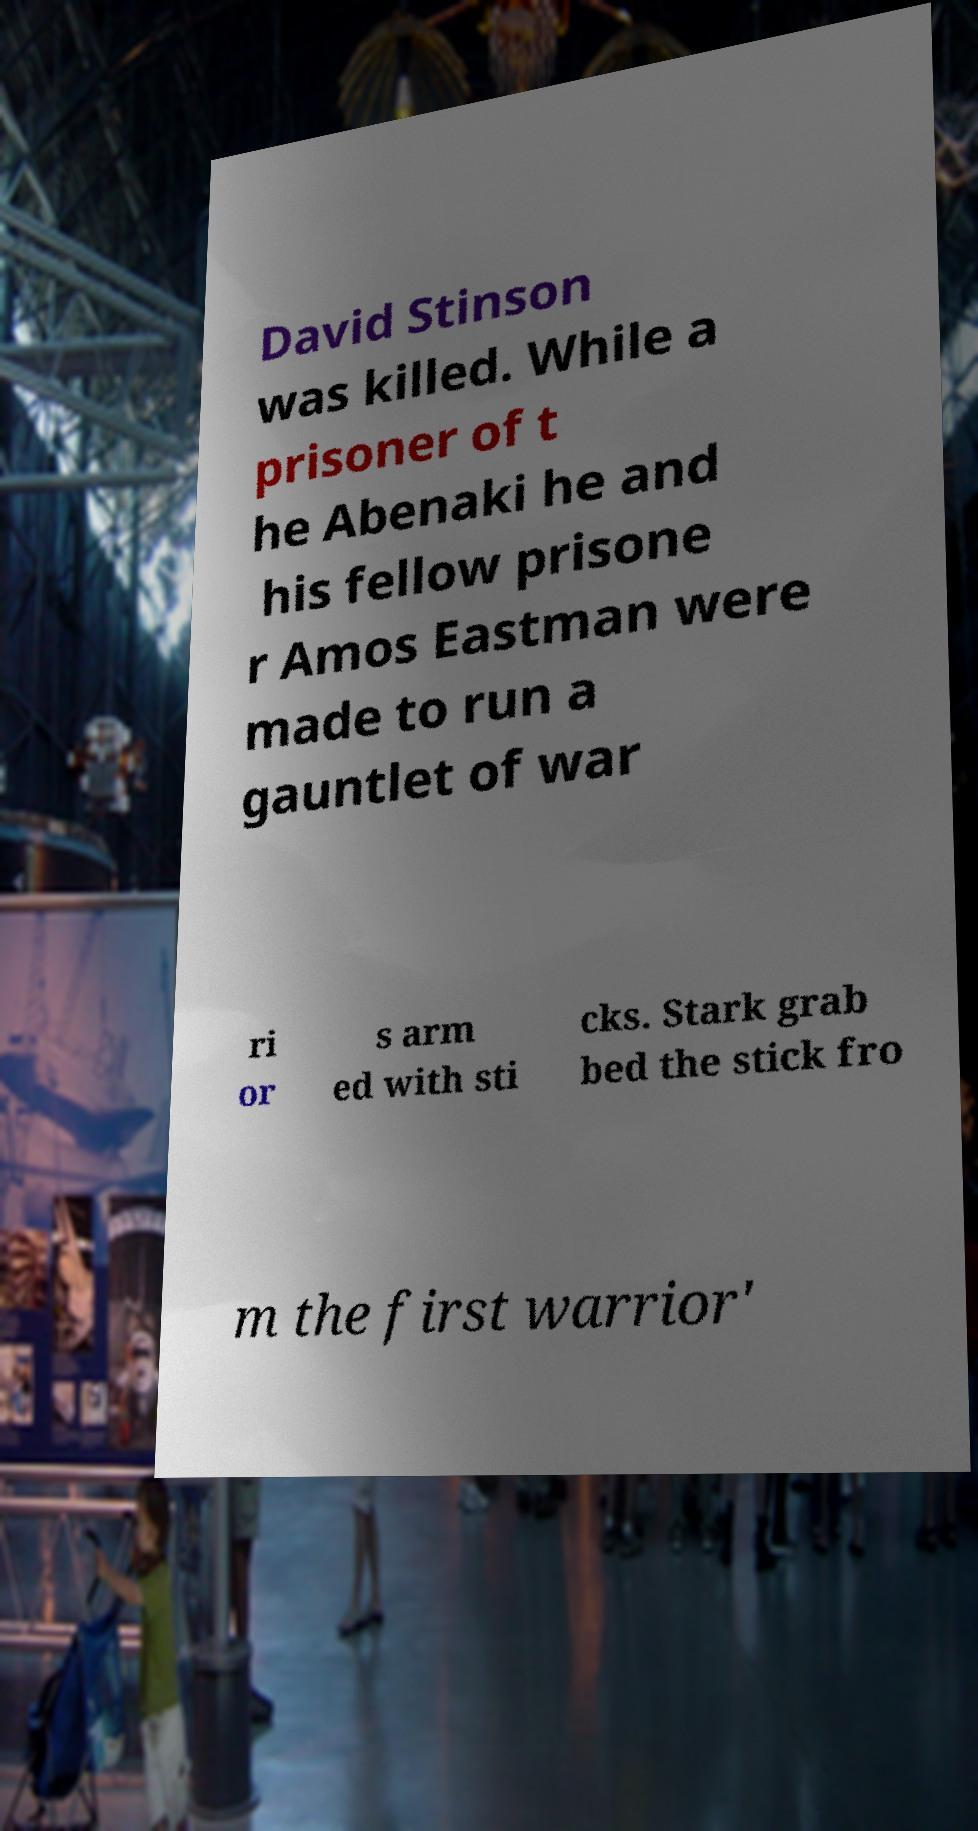Could you assist in decoding the text presented in this image and type it out clearly? David Stinson was killed. While a prisoner of t he Abenaki he and his fellow prisone r Amos Eastman were made to run a gauntlet of war ri or s arm ed with sti cks. Stark grab bed the stick fro m the first warrior' 